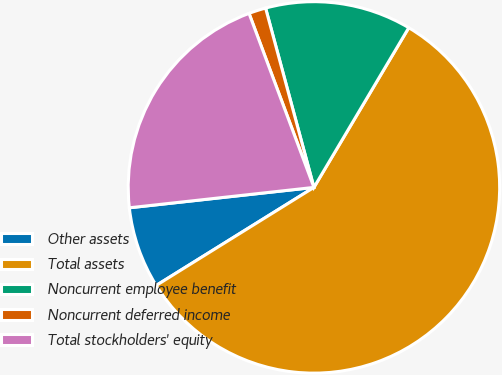Convert chart. <chart><loc_0><loc_0><loc_500><loc_500><pie_chart><fcel>Other assets<fcel>Total assets<fcel>Noncurrent employee benefit<fcel>Noncurrent deferred income<fcel>Total stockholders' equity<nl><fcel>7.1%<fcel>57.62%<fcel>12.72%<fcel>1.49%<fcel>21.07%<nl></chart> 